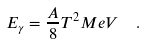Convert formula to latex. <formula><loc_0><loc_0><loc_500><loc_500>E _ { \gamma } = \frac { A } { 8 } T ^ { 2 } M e V \ \ .</formula> 